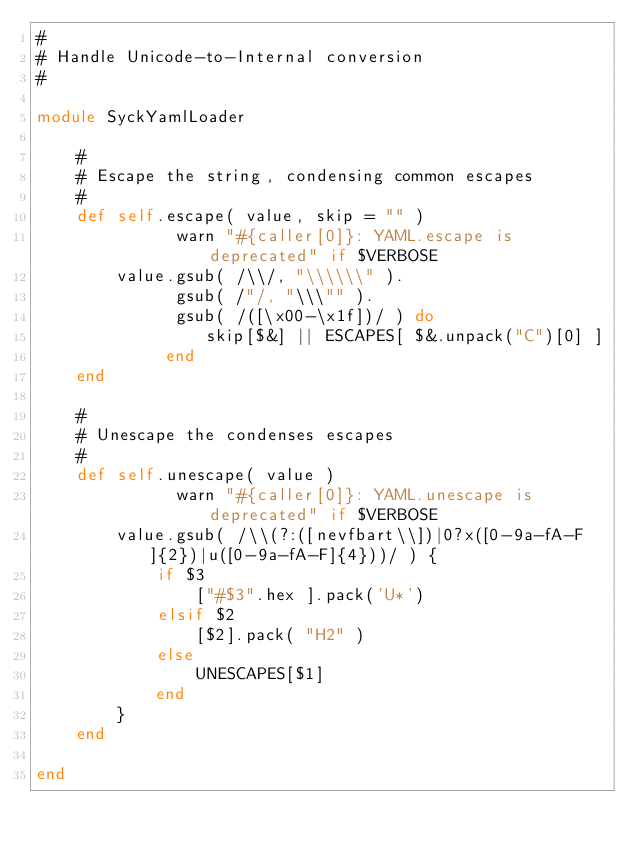Convert code to text. <code><loc_0><loc_0><loc_500><loc_500><_Ruby_>#
# Handle Unicode-to-Internal conversion
#

module SyckYamlLoader

	#
	# Escape the string, condensing common escapes
	#
	def self.escape( value, skip = "" )
              warn "#{caller[0]}: YAML.escape is deprecated" if $VERBOSE
		value.gsub( /\\/, "\\\\\\" ).
              gsub( /"/, "\\\"" ).
              gsub( /([\x00-\x1f])/ ) do
                 skip[$&] || ESCAPES[ $&.unpack("C")[0] ]
             end
	end

	#
	# Unescape the condenses escapes
	#
	def self.unescape( value )
              warn "#{caller[0]}: YAML.unescape is deprecated" if $VERBOSE
		value.gsub( /\\(?:([nevfbart\\])|0?x([0-9a-fA-F]{2})|u([0-9a-fA-F]{4}))/ ) {
			if $3
				["#$3".hex ].pack('U*')
			elsif $2
				[$2].pack( "H2" )
			else
				UNESCAPES[$1]
			end
		}
	end

end
</code> 